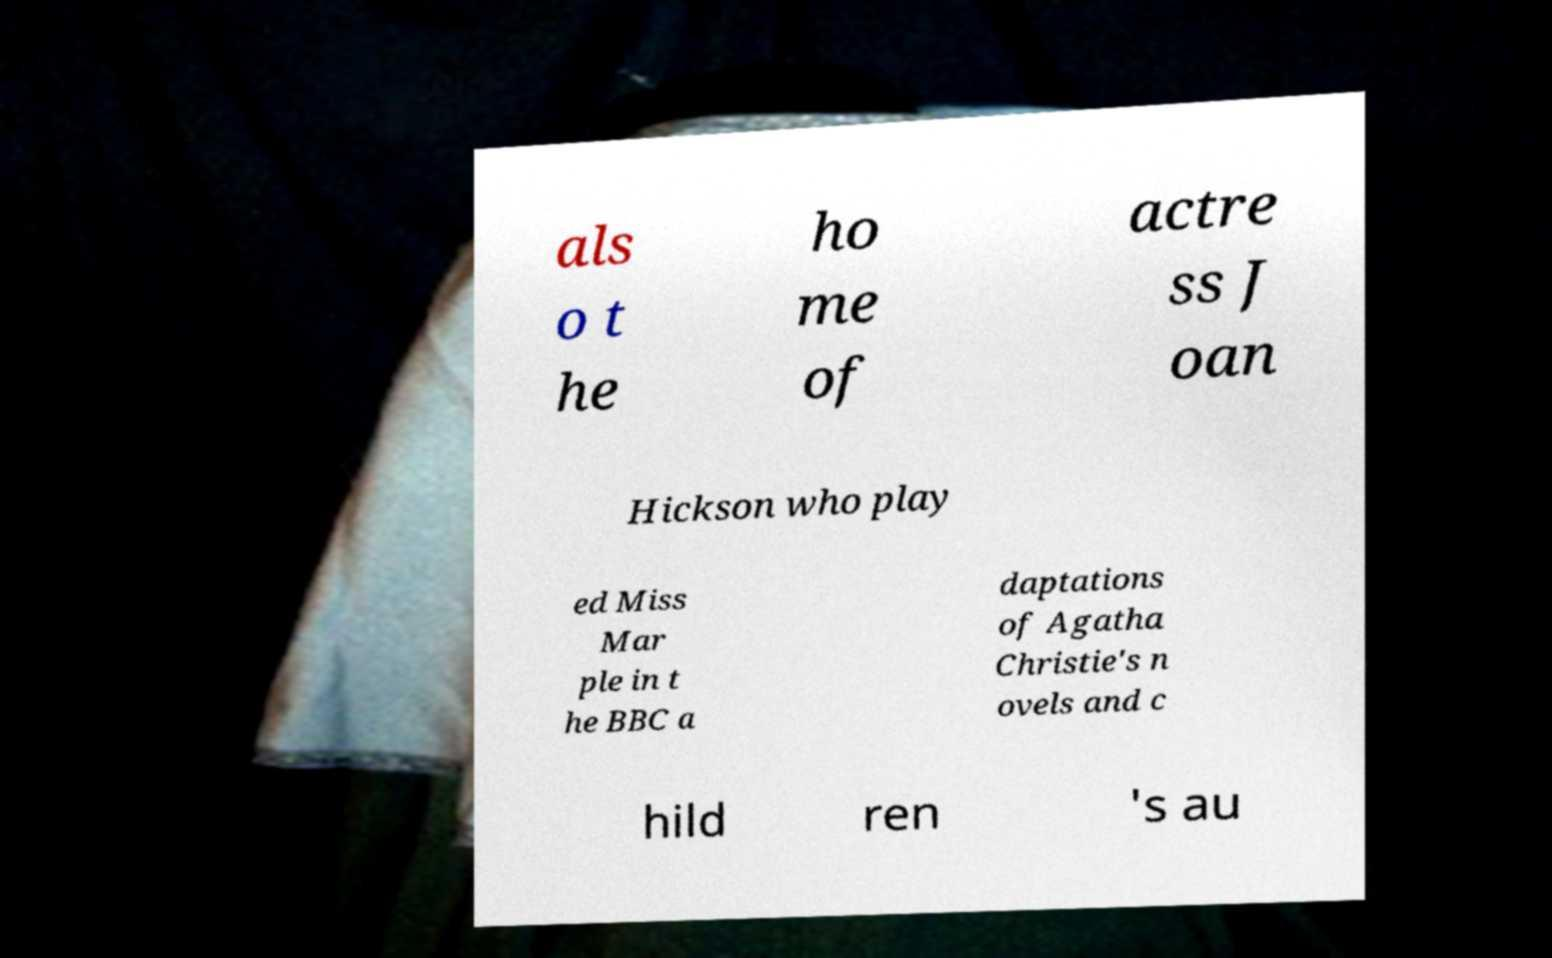Could you assist in decoding the text presented in this image and type it out clearly? als o t he ho me of actre ss J oan Hickson who play ed Miss Mar ple in t he BBC a daptations of Agatha Christie's n ovels and c hild ren 's au 